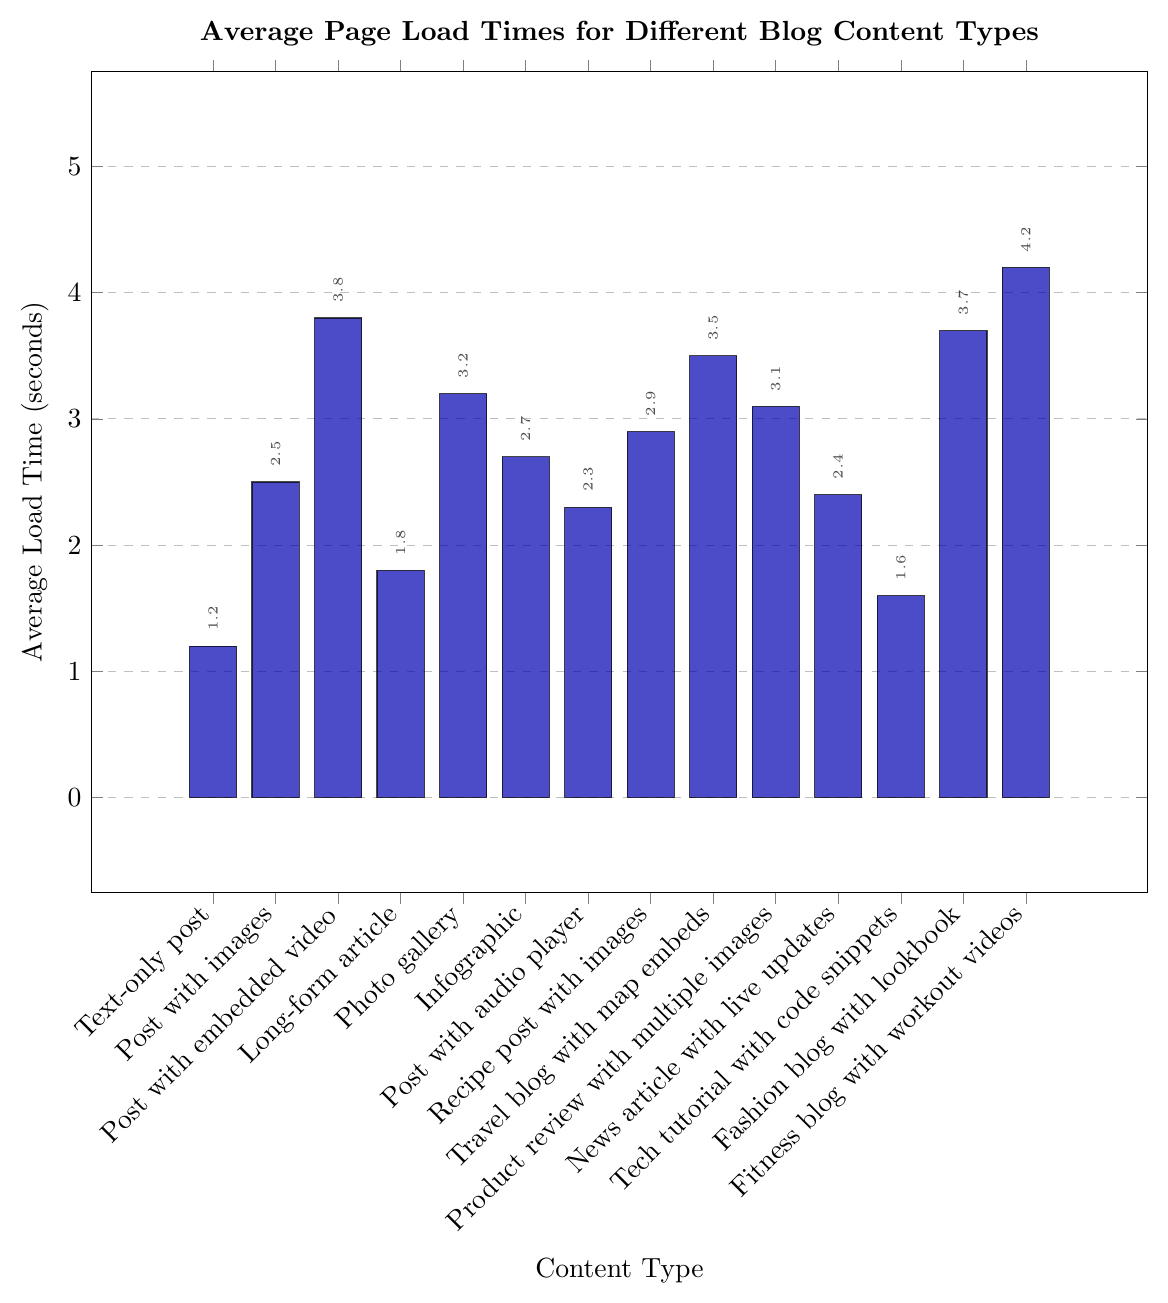What is the average load time for a post with images? The bar for "Post with images" is labeled as 2.5 seconds, which indicates the average load time.
Answer: 2.5 seconds Which content type has the highest average load time, and what is that time? The tallest bar on the chart corresponds to "Fitness blog with workout videos," indicating the highest average load time of 4.2 seconds.
Answer: Fitness blog with workout videos, 4.2 seconds How much longer, on average, does a fitness blog with workout videos take to load compared to a text-only post? A fitness blog with workout videos takes 4.2 seconds to load, whereas a text-only post takes 1.2 seconds. Subtracting these gives 4.2 - 1.2 = 3 seconds longer.
Answer: 3 seconds What is the average load time difference between a tech tutorial with code snippets and a long-form article? A tech tutorial with code snippets has an average load time of 1.6 seconds, and a long-form article has 1.8 seconds. The difference is 1.8 - 1.6 = 0.2 seconds.
Answer: 0.2 seconds What is the combined average load time of a news article with live updates and a fashion blog with lookbook? A news article with live updates has an average load time of 2.4 seconds, and a fashion blog with lookbook has 3.7 seconds. The combined load time is 2.4 + 3.7 = 6.1 seconds.
Answer: 6.1 seconds What is the median average load time for all the content types shown in the chart? First, list all the average load times in ascending order: 1.2, 1.6, 1.8, 2.3, 2.4, 2.5, 2.7, 2.9, 3.1, 3.2, 3.5, 3.7, 3.8, 4.2.
The median is the middle value of this sorted list. With 14 values, the middle two values are the 7th and 8th values, which are 2.7 and 2.9. The median is the average of these two values: (2.7 + 2.9) / 2 = 2.8 seconds.
Answer: 2.8 seconds Which content type has the lowest average load time? The shortest bar on the chart corresponds to "Text-only post," with an average load time of 1.2 seconds.
Answer: Text-only post How much longer does it take, on average, for a post with embedded video to load than an infographic? A post with embedded video has an average load time of 3.8 seconds, and an infographic has 2.7 seconds. The difference is 3.8 - 2.7 = 1.1 seconds.
Answer: 1.1 seconds 